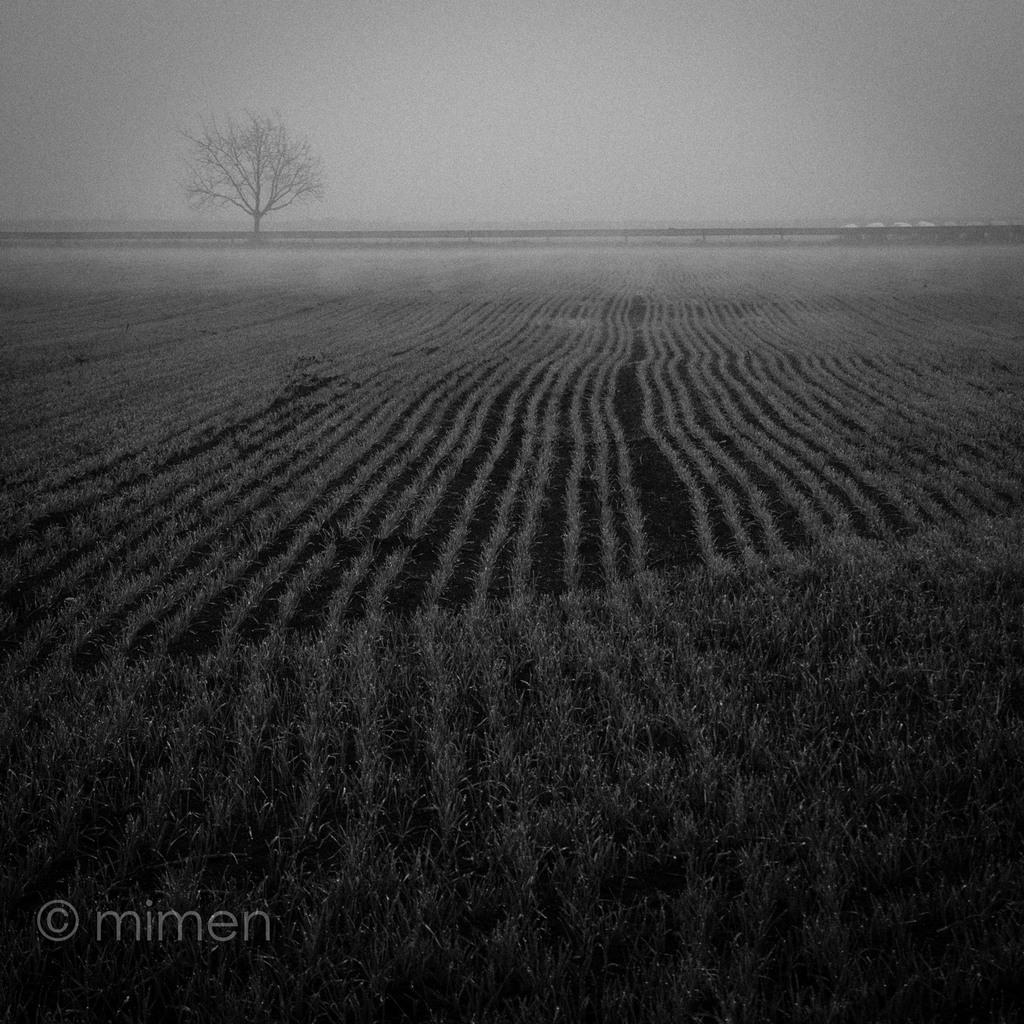What is the color scheme of the image? The image is black and white. What type of landscape can be seen in the image? There is farmland in the image. What natural element is present in the image? There is a tree in the image. What can be seen in the background of the image? The sky is visible in the background of the image. How many pieces of furniture are visible in the image? There are no pieces of furniture present in the image. Can you describe the pig that is walking through the farmland in the image? There is no pig present in the image; it only features farmland, a tree, and the sky. 